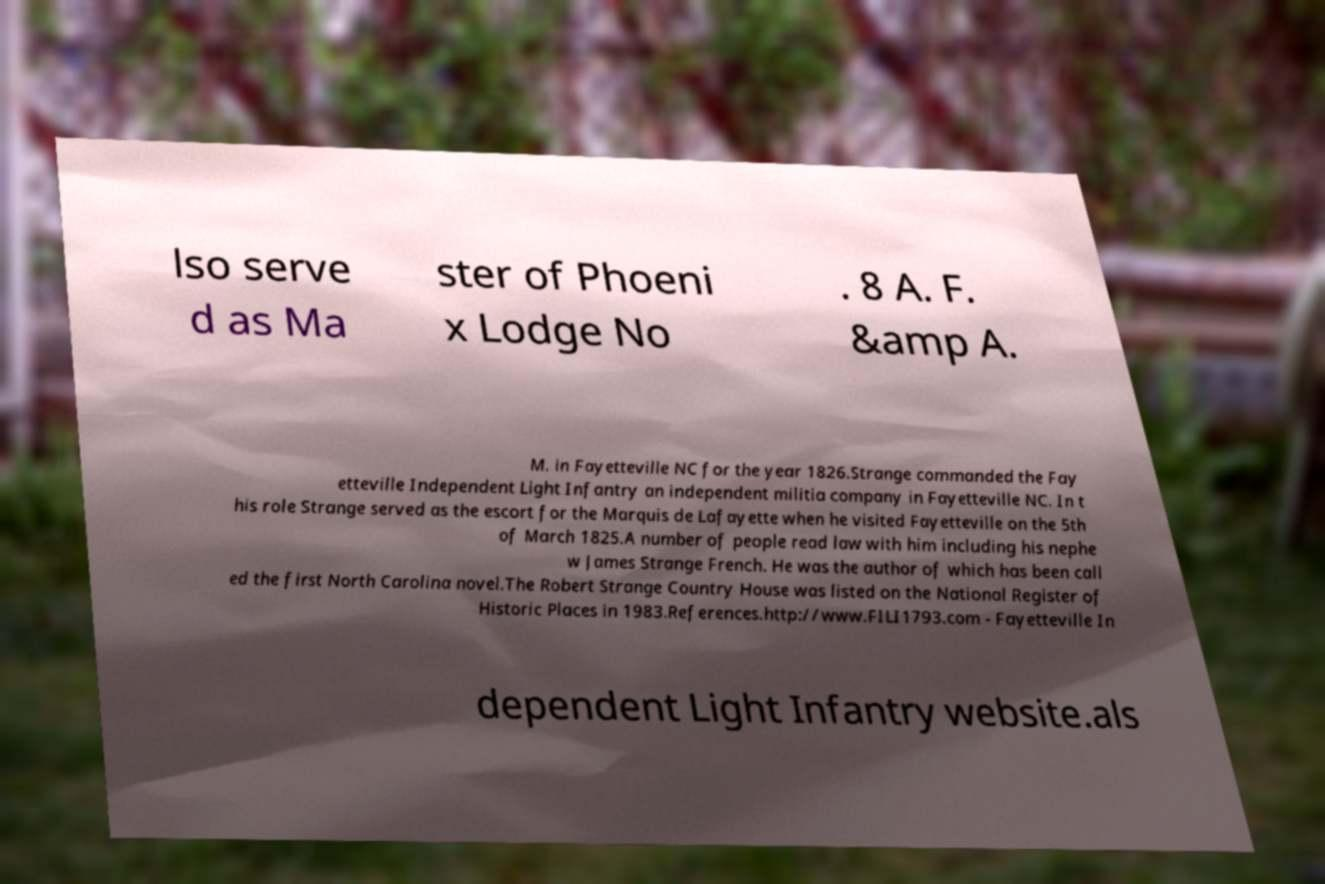Can you accurately transcribe the text from the provided image for me? lso serve d as Ma ster of Phoeni x Lodge No . 8 A. F. &amp A. M. in Fayetteville NC for the year 1826.Strange commanded the Fay etteville Independent Light Infantry an independent militia company in Fayetteville NC. In t his role Strange served as the escort for the Marquis de Lafayette when he visited Fayetteville on the 5th of March 1825.A number of people read law with him including his nephe w James Strange French. He was the author of which has been call ed the first North Carolina novel.The Robert Strange Country House was listed on the National Register of Historic Places in 1983.References.http://www.FILI1793.com - Fayetteville In dependent Light Infantry website.als 